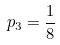<formula> <loc_0><loc_0><loc_500><loc_500>p _ { 3 } = \frac { 1 } { 8 }</formula> 